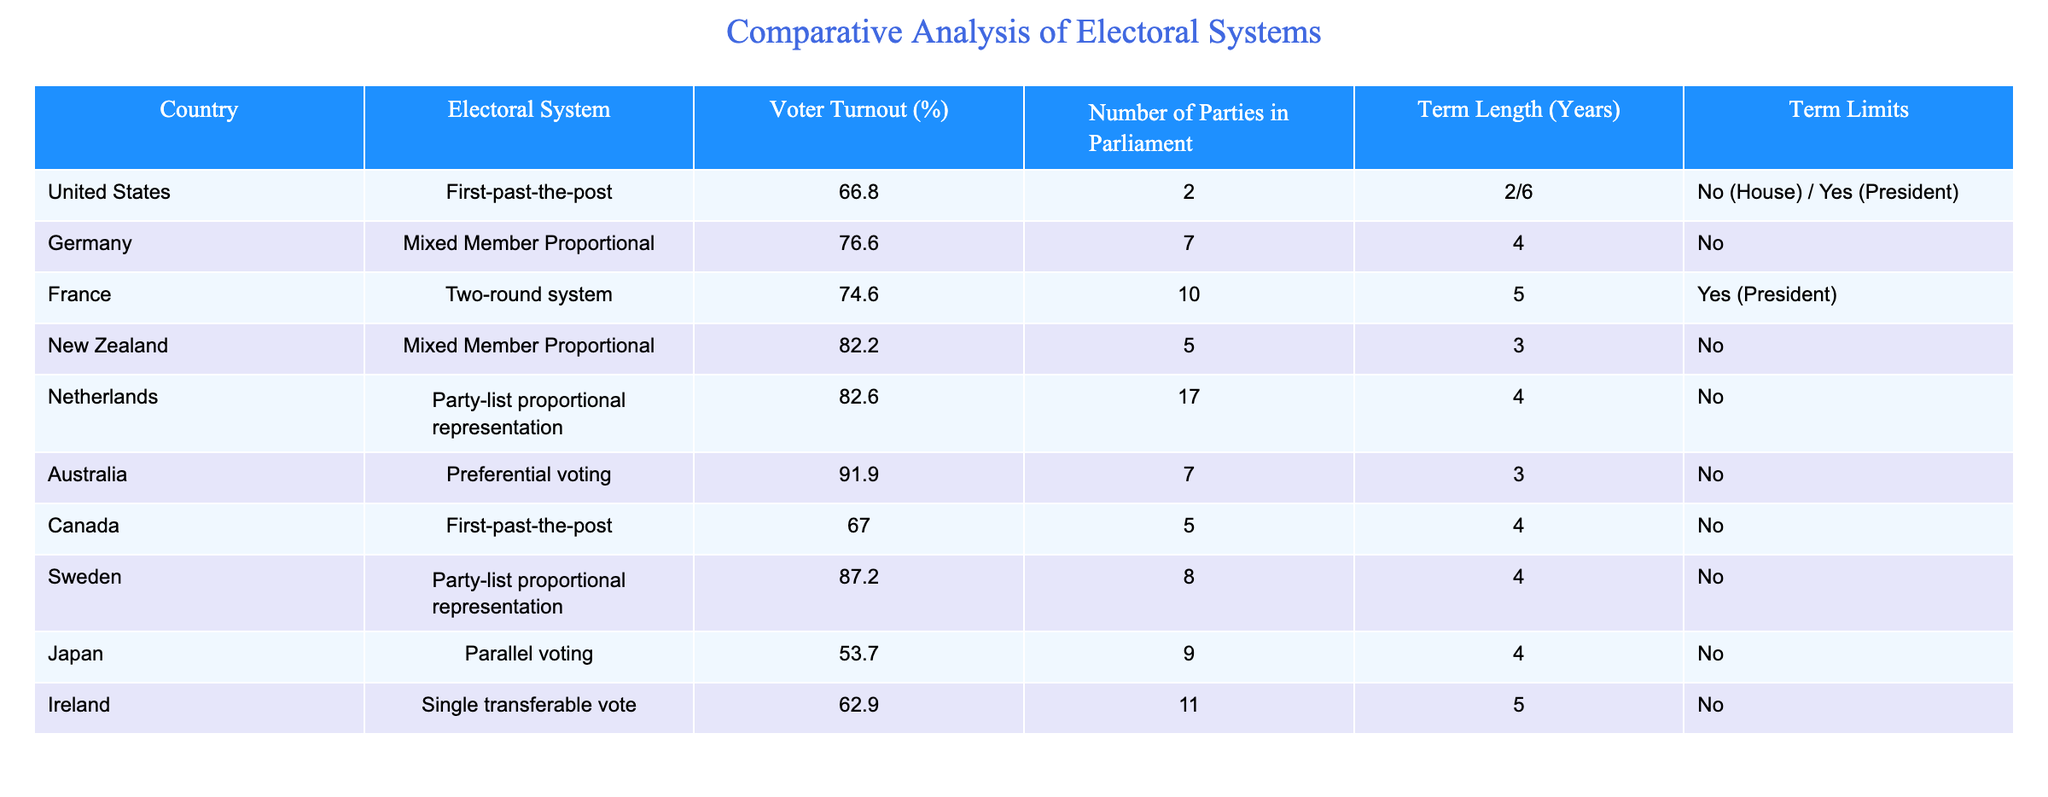What is the voter turnout percentage in Australia? The table shows the voter turnout percentage for each country listed. For Australia, it specifically states 91.9%.
Answer: 91.9% Which electoral system does Germany use? The table directly lists Germany's electoral system under the corresponding column, which is "Mixed Member Proportional".
Answer: Mixed Member Proportional How many parties are there in the Netherlands parliament? Referring to the "Number of Parties in Parliament" column, the table indicates that there are 17 parties in the Netherlands.
Answer: 17 What is the average voter turnout percentage among the countries listed? To find the average voter turnout, add the percentages (66.8 + 76.6 + 74.6 + 82.2 + 82.6 + 91.9 + 67 + 87.2 + 53.7 + 62.9) which totals  818.5. Then, divide by the number of countries (10), resulting in an average of 81.85%.
Answer: 81.85% Is there a country listed with term limits for its legislators? The table indicates that France has term limits, specifically noted in the "Term Limits" column for the President. All other countries listed show "No."
Answer: Yes What is the difference in voter turnout percentage between the United States and Sweden? The table states that the United States has a voter turnout percentage of 66.8% and Sweden has 87.2%. By subtracting the United States' percentage from Sweden's (87.2 - 66.8), the difference is 20.4%.
Answer: 20.4% Which country has the shortest term length for legislators? Looking at the "Term Length" column, I see that New Zealand has the shortest term length of 3 years.
Answer: New Zealand How many countries listed have a first-past-the-post electoral system? By scanning the table, both the United States and Canada use the first-past-the-post electoral system, totaling 2 countries.
Answer: 2 What is the term length for the President in France? The table specifies that the term length for the President in France is 5 years.
Answer: 5 years 